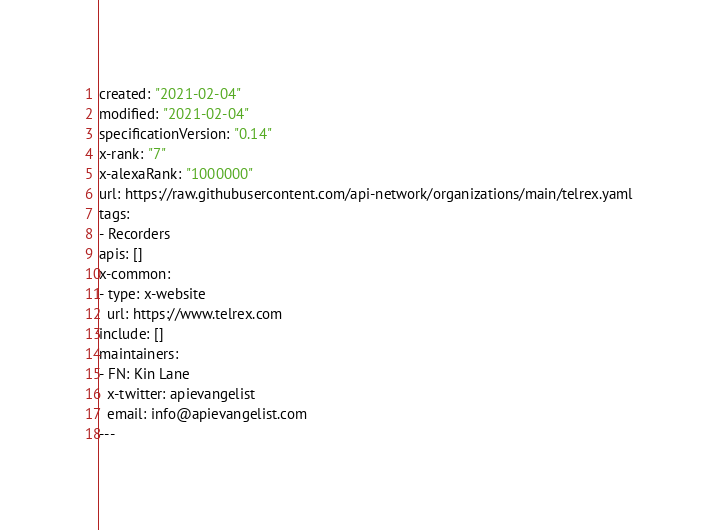Convert code to text. <code><loc_0><loc_0><loc_500><loc_500><_YAML_>created: "2021-02-04"
modified: "2021-02-04"
specificationVersion: "0.14"
x-rank: "7"
x-alexaRank: "1000000"
url: https://raw.githubusercontent.com/api-network/organizations/main/telrex.yaml
tags:
- Recorders
apis: []
x-common:
- type: x-website
  url: https://www.telrex.com
include: []
maintainers:
- FN: Kin Lane
  x-twitter: apievangelist
  email: info@apievangelist.com
---</code> 